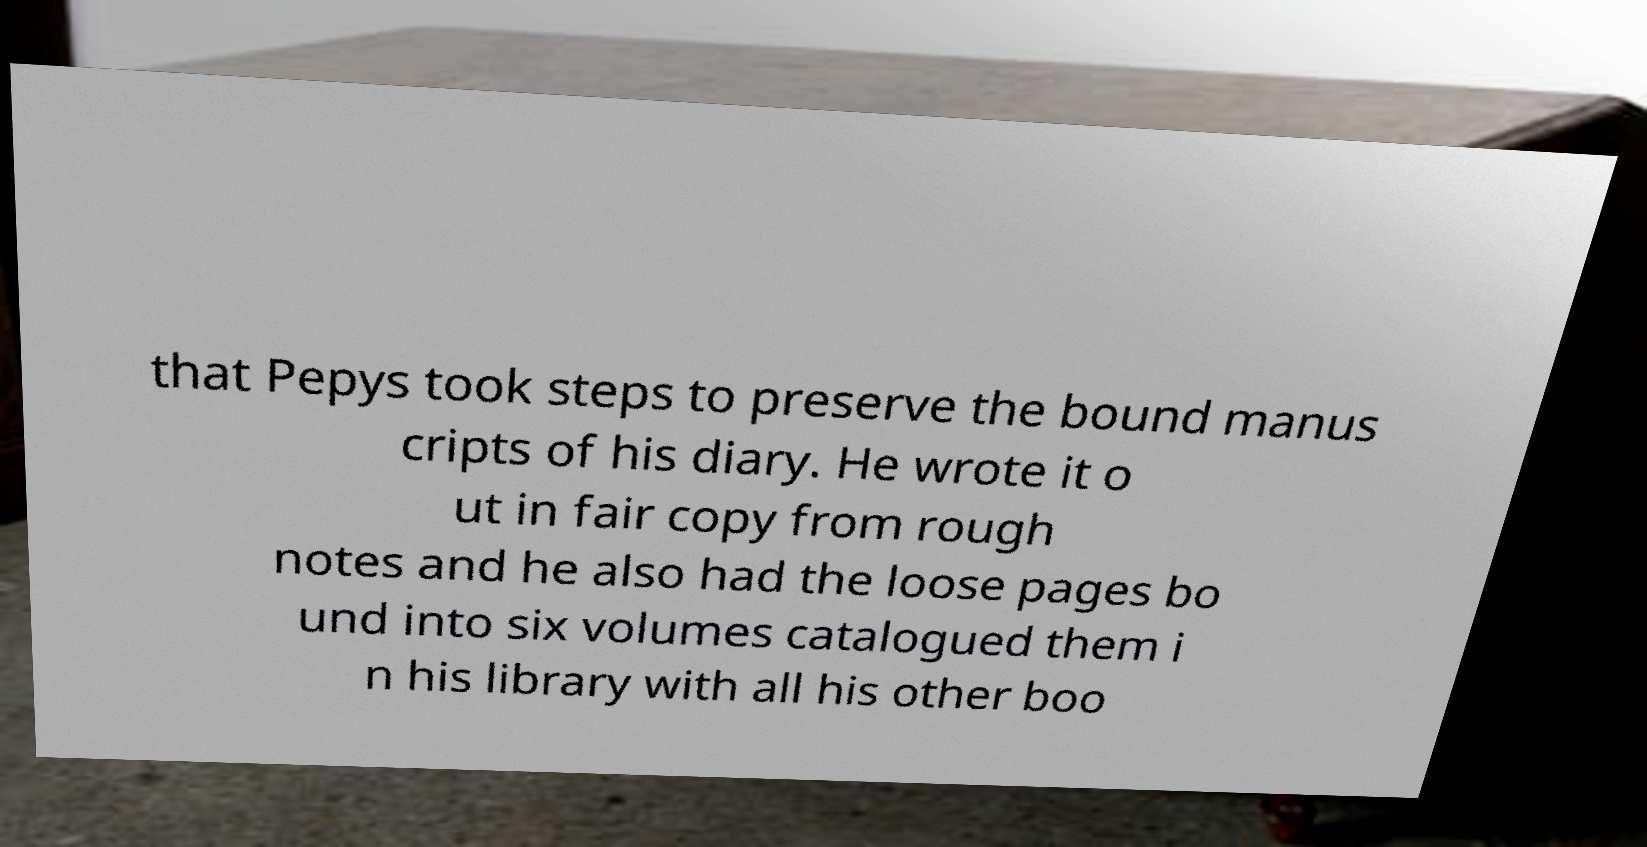Can you accurately transcribe the text from the provided image for me? that Pepys took steps to preserve the bound manus cripts of his diary. He wrote it o ut in fair copy from rough notes and he also had the loose pages bo und into six volumes catalogued them i n his library with all his other boo 